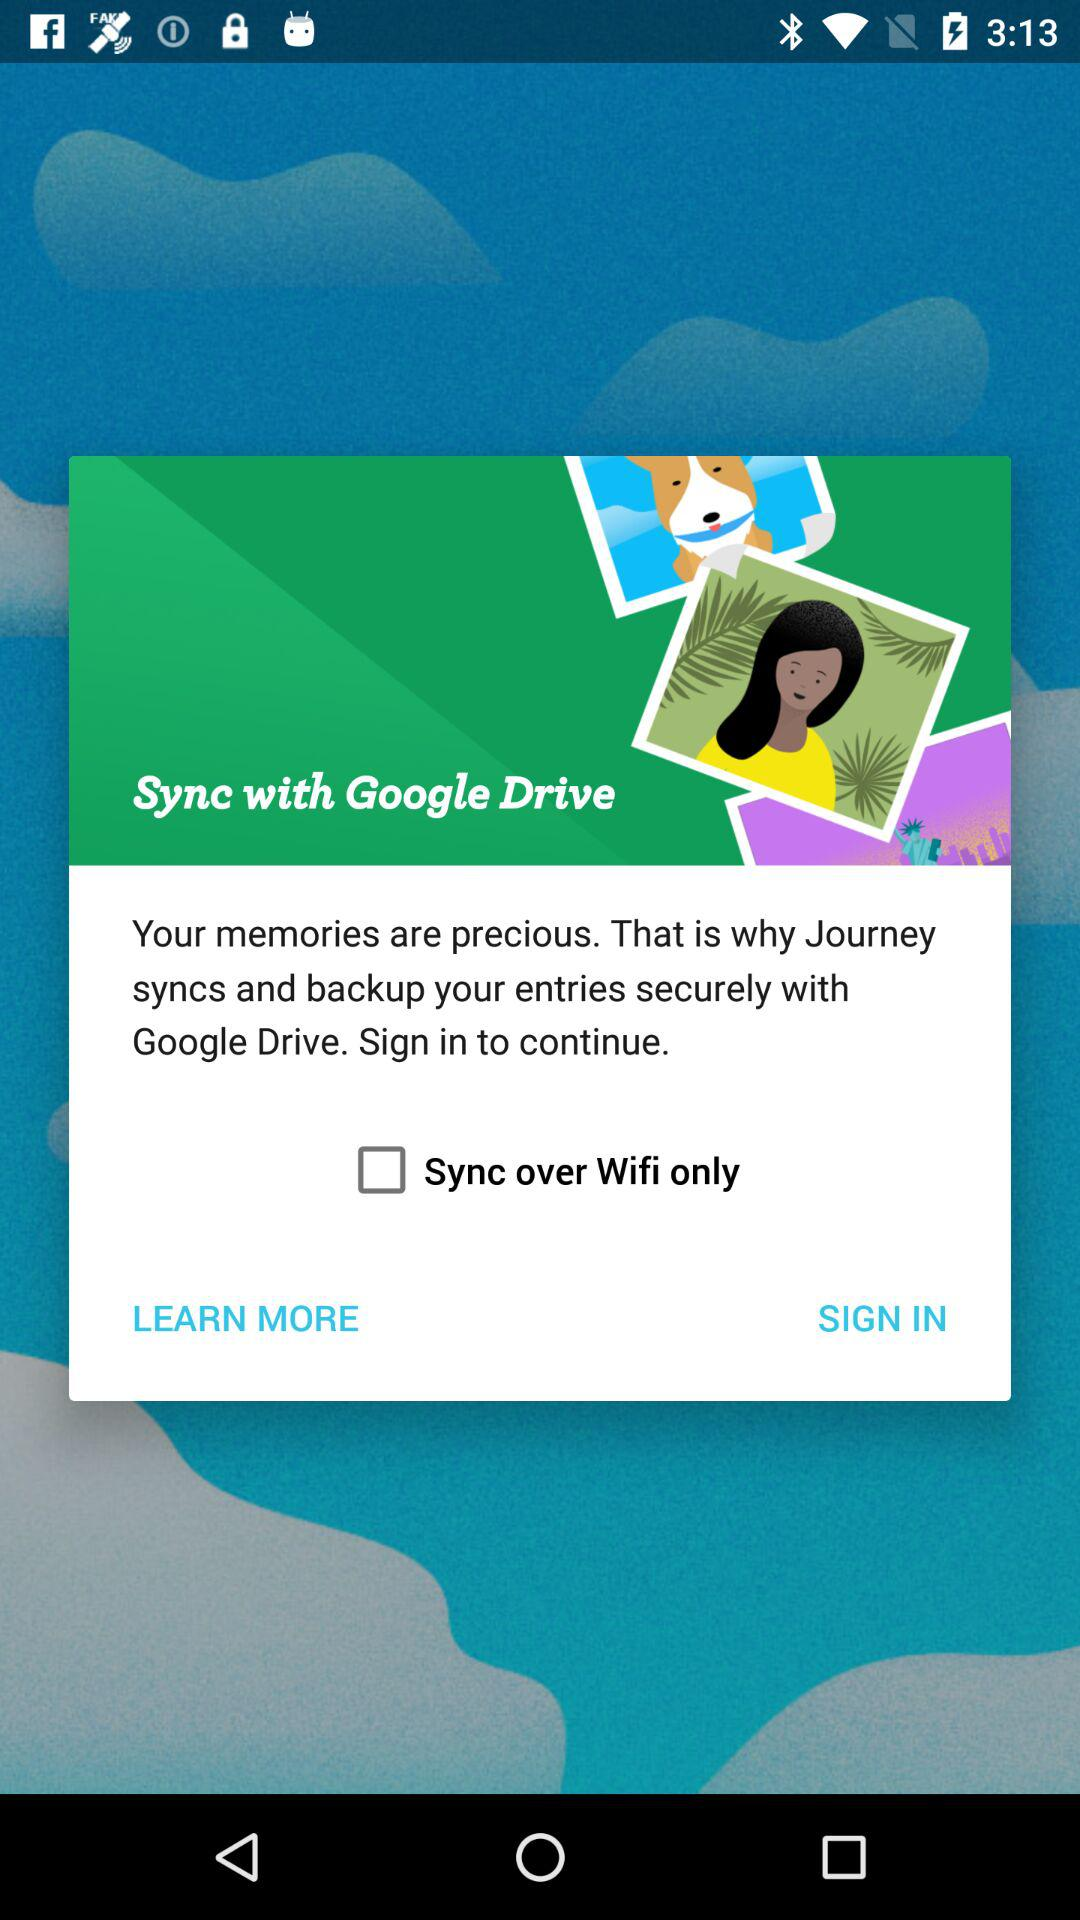Where do the entries sync and get back up securely? The entries sync and get back up securely in "Google Drive". 